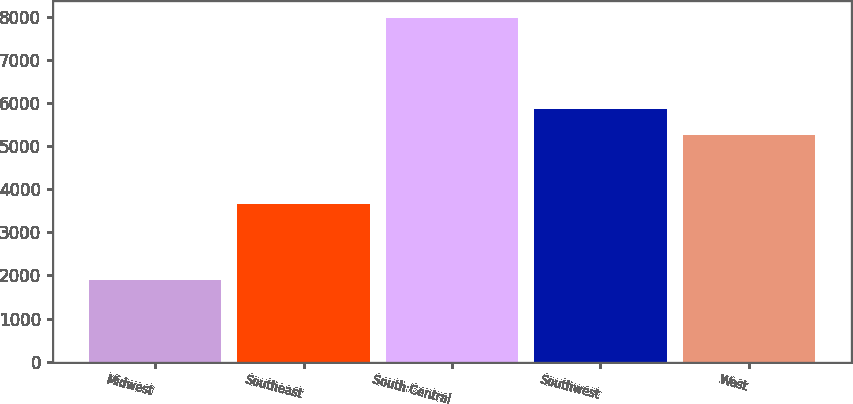Convert chart to OTSL. <chart><loc_0><loc_0><loc_500><loc_500><bar_chart><fcel>Midwest<fcel>Southeast<fcel>South Central<fcel>Southwest<fcel>West<nl><fcel>1905<fcel>3650<fcel>7960<fcel>5868.5<fcel>5263<nl></chart> 